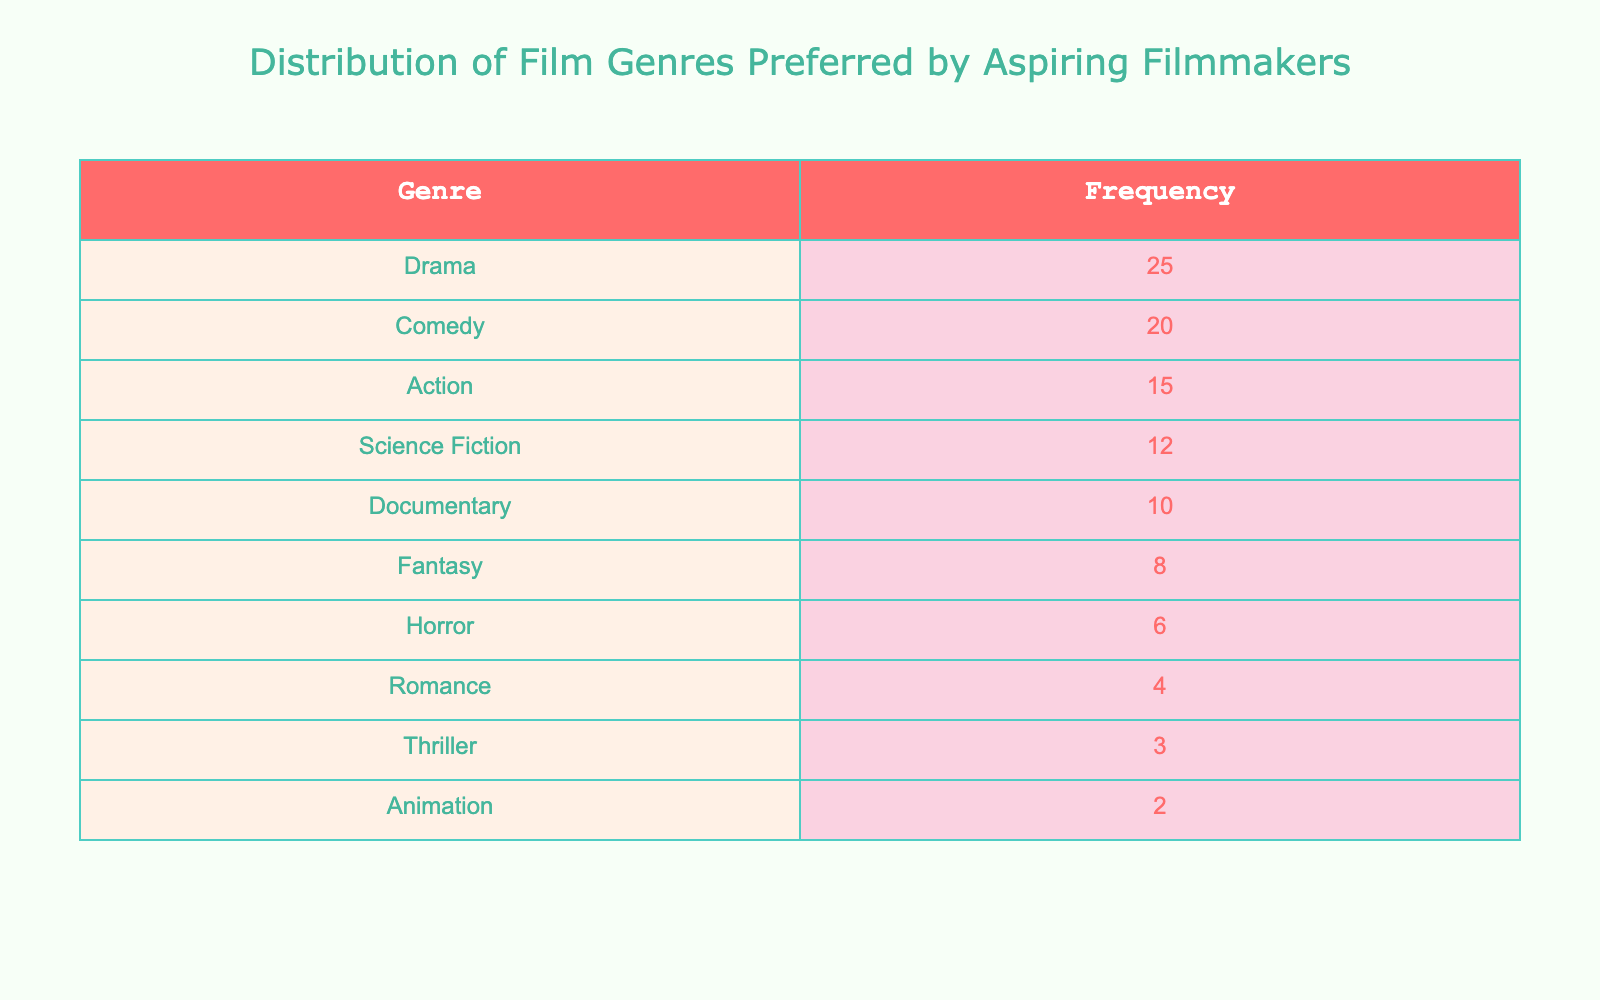What is the most preferred genre among aspiring filmmakers? The table lists various film genres along with their corresponding frequencies. Looking at the frequencies, "Drama" has the highest frequency of 25, which indicates that it is the most preferred genre among aspiring filmmakers.
Answer: Drama How many filmmakers prefer "Animation" compared to "Horror"? The frequency for "Animation" is 2 and for "Horror" is 6. To compare, we see that "Horror" has a frequency that is 4 higher than "Animation" (6 - 2 = 4).
Answer: Horror has 4 more filmmakers What is the total number of filmmakers represented in this table? To find the total, we sum up all the frequencies: 25 (Drama) + 20 (Comedy) + 15 (Action) + 12 (Science Fiction) + 10 (Documentary) + 8 (Fantasy) + 6 (Horror) + 4 (Romance) + 3 (Thriller) + 2 (Animation) = 105.
Answer: 105 Is "Romance" more preferred than "Science Fiction"? The frequency for "Romance" is 4 while "Science Fiction" has a frequency of 12. Since 4 is less than 12, "Romance" is not preferred more than "Science Fiction".
Answer: No What percentage of aspiring filmmakers prefer "Comedy"? To find the percentage, we take the frequency of "Comedy" (20), divide it by the total number of filmmakers (105), and multiply by 100: (20 / 105) * 100 = approximately 19.05%. This represents the percentage of filmmakers who prefer "Comedy".
Answer: Approximately 19.05% Which genres together have a total frequency greater than 40? We examine the frequencies of genres. "Drama" (25) + "Comedy" (20) = 45, which is greater than 40. The combination of both genres alone exceeds 40. Additionally, "Drama" + "Action" (25 + 15 = 40) is exactly 40. However, "Comedy" alone with other genres like "Science Fiction" total to above 40 as well.
Answer: Drama and Comedy How many genres have a frequency of 10 or less? The genres with 10 or less frequencies are "Documentary" (10), "Fantasy" (8), "Horror" (6), "Romance" (4), "Thriller" (3), and "Animation" (2). Counting these gives us 6 genres.
Answer: 6 What is the difference in frequency between "Action" and "Thriller"? The frequency for "Action" is 15 and for "Thriller" is 3. To find the difference, we subtract the frequency of "Thriller" from "Action": 15 - 3 = 12.
Answer: 12 